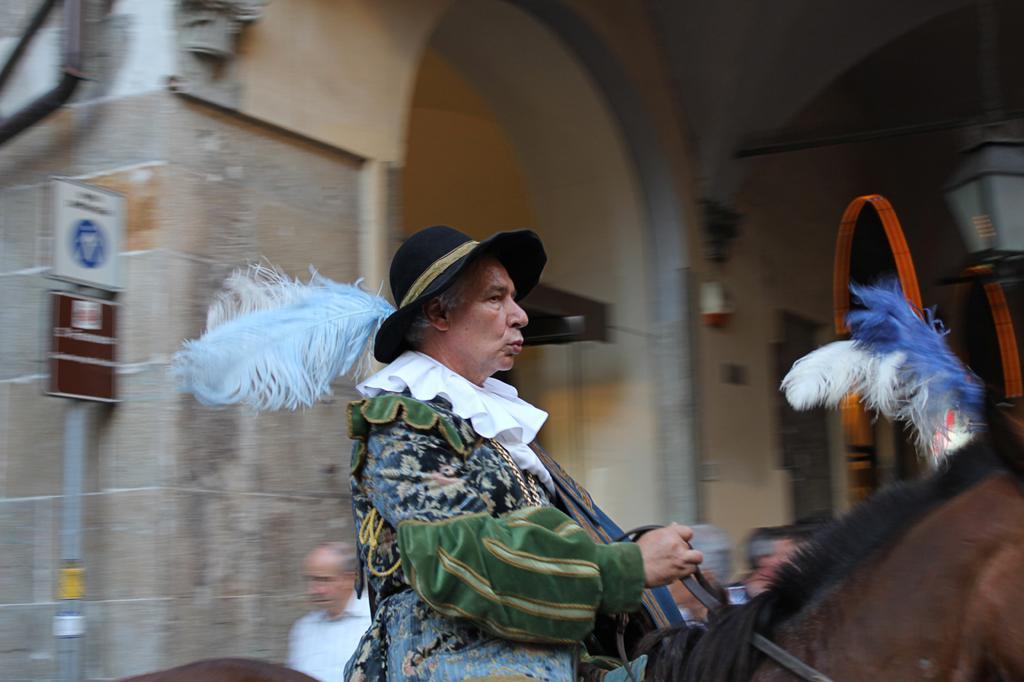Can you describe this image briefly? In the picture we can see a man with a costume and wearing a black hat and white feather to it and sitting on the horse and riding it and behind him we can see a building and some pole with a board. 